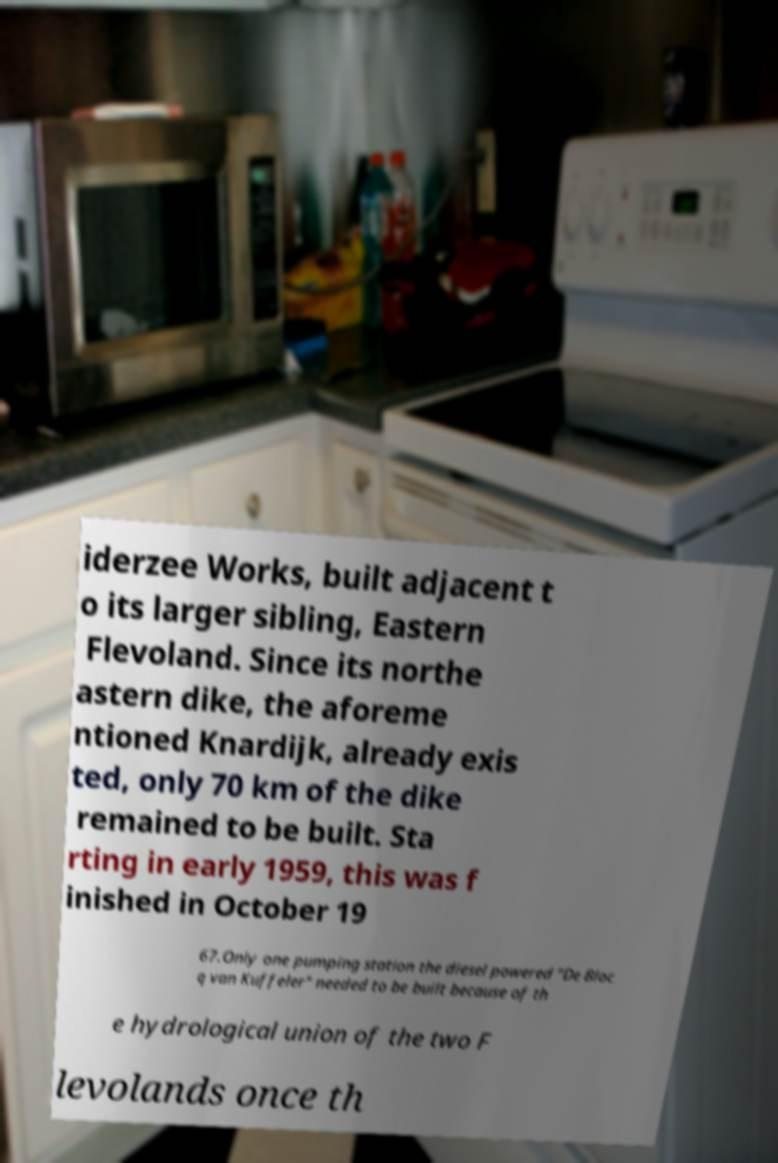Can you accurately transcribe the text from the provided image for me? iderzee Works, built adjacent t o its larger sibling, Eastern Flevoland. Since its northe astern dike, the aforeme ntioned Knardijk, already exis ted, only 70 km of the dike remained to be built. Sta rting in early 1959, this was f inished in October 19 67.Only one pumping station the diesel powered "De Bloc q van Kuffeler" needed to be built because of th e hydrological union of the two F levolands once th 